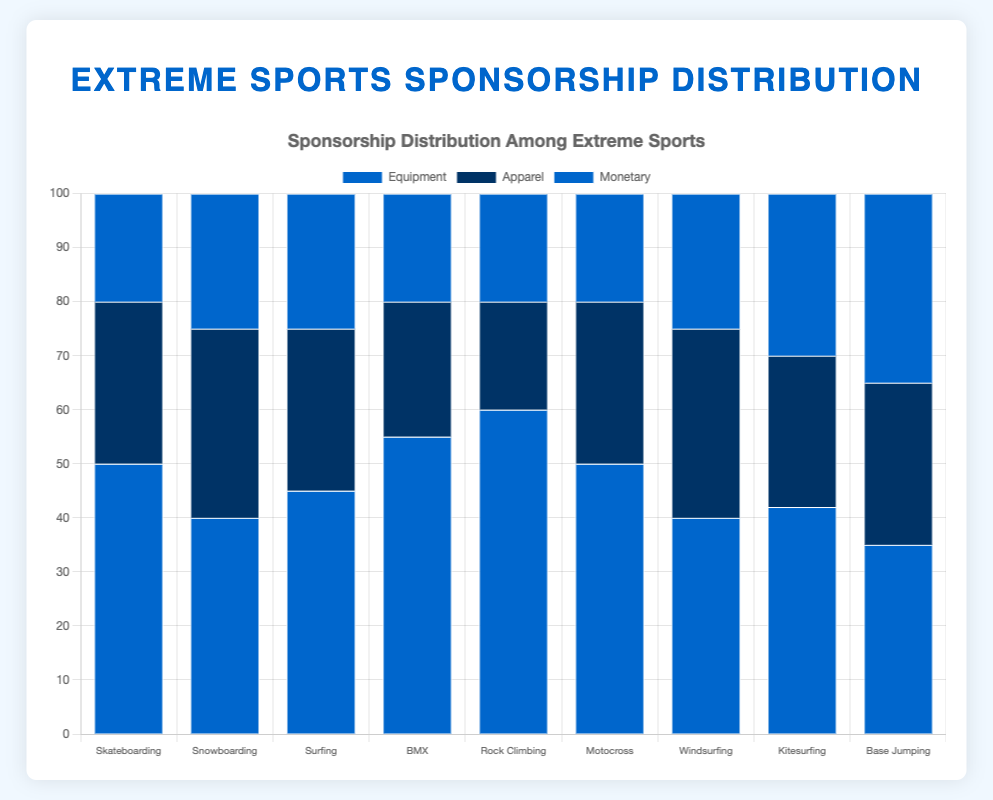What sport receives the most equipment sponsorships? To determine which sport receives the most equipment sponsorship, look at the heights of the blue bars corresponding to "Equipment." The tallest blue bar will indicate the sport with the highest amount of equipment sponsorship. Rock Climbing receives 60 units, which is the highest.
Answer: Rock Climbing Which sport has the lowest amount of apparel sponsorship? Check the heights of the dark blue bars labeled "Apparel" for each sport. The lowest height represents the sport with the least apparel sponsorship. Rock Climbing has 20 units, which is the lowest.
Answer: Rock Climbing What is the total sponsorship amount for Motocross? Add the sponsorship amounts for equipment (50), apparel (30), and monetary (20) in Motocross. The sum is 50 + 30 + 20 = 100 units.
Answer: 100 units Which sports have equal amounts of monetary sponsorship? Compare the dark blue bars labeled "Monetary" across different sports to find the ones with the same height. Skateboarding, BMX, Rock Climbing, and Motocross each receive 20 units of monetary sponsorship.
Answer: Skateboarding, BMX, Rock Climbing, Motocross How does the equipment sponsorship for Windsurfing compare to that of Kitesurfing? Look at the heights of the blue bars labeled "Equipment" for both Windsurfing and Kitesurfing. Windsurfing has 40 units while Kitesurfing has 42 units. Windsurfing has 2 units less than Kitesurfing.
Answer: Kitesurfing has 2 units more than Windsurfing What is the difference in total sponsorship amounts between Skateboarding and Snowboarding? Add up the sponsorship amounts for each type in both sports. For Skateboarding: 50 (Equipment) + 30 (Apparel) + 20 (Monetary) = 100 units. For Snowboarding: 40 (Equipment) + 35 (Apparel) + 25 (Monetary) = 100 units. The difference is 100 - 100 = 0 units.
Answer: 0 units Which sport has the highest combined amount of equipment and apparel sponsorships? Add the amounts of equipment and apparel sponsorships for each sport. The sport with the highest sum is the answer. Rock Climbing: 60 (Equipment) + 20 (Apparel) = 80 units. No other sport exceeds this amount.
Answer: Rock Climbing How much more monetary sponsorship does Base Jumping receive compared to Skateboarding? Look at the dark blue bars labeled "Monetary" for Base Jumping (35 units) and Skateboarding (20 units). Subtract the amounts: 35 - 20 = 15 units.
Answer: 15 units 